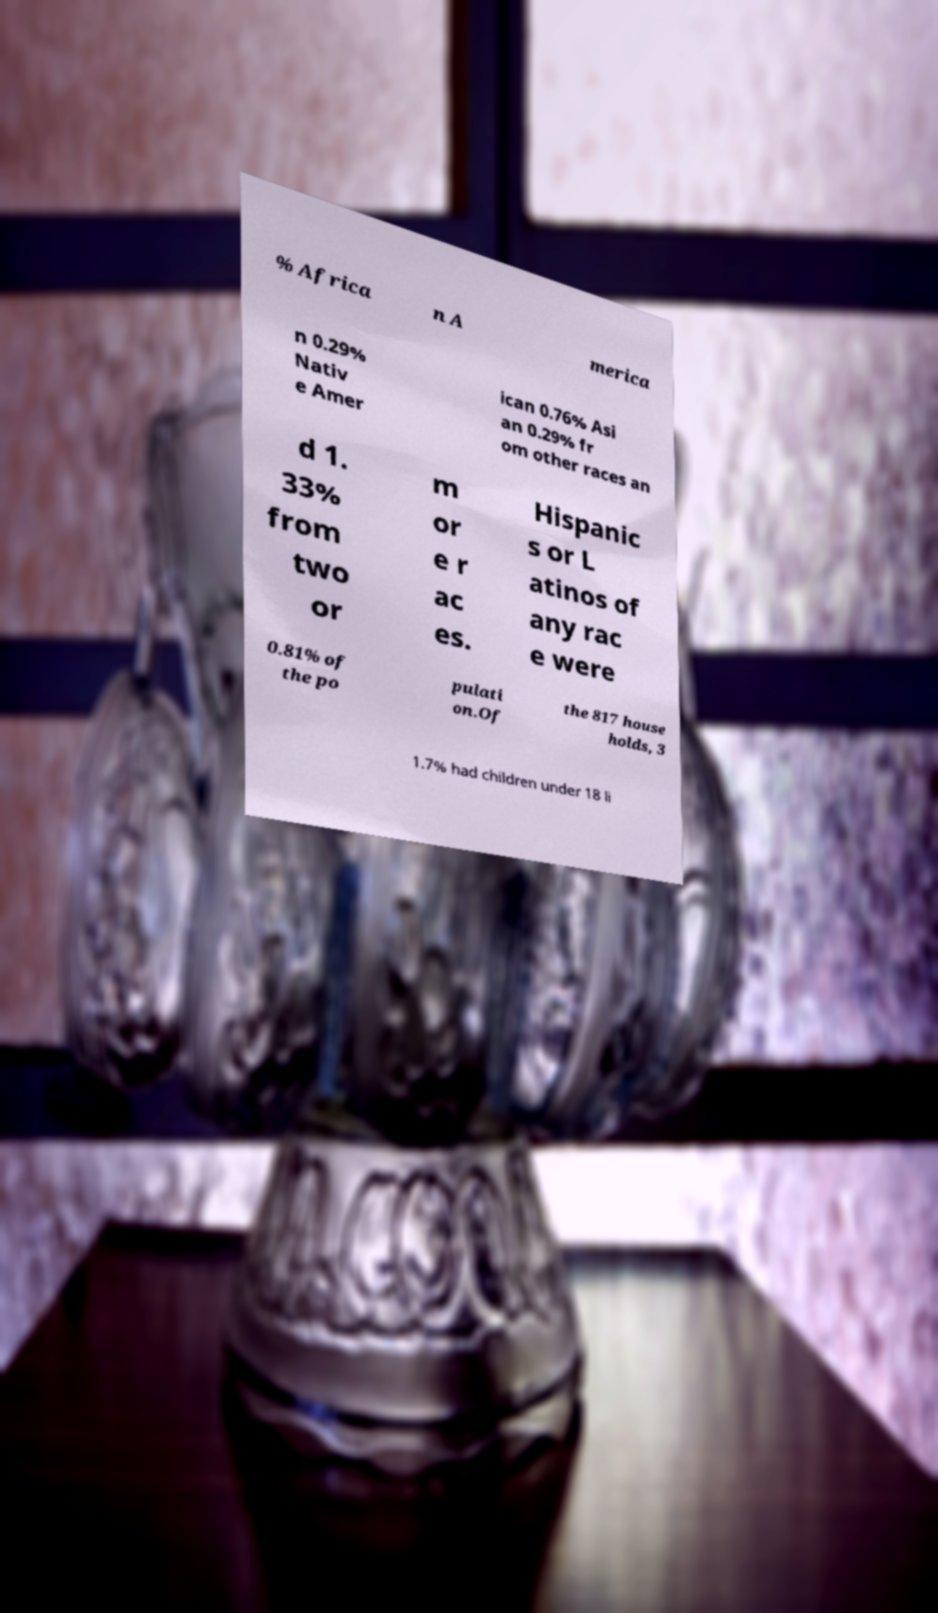What messages or text are displayed in this image? I need them in a readable, typed format. % Africa n A merica n 0.29% Nativ e Amer ican 0.76% Asi an 0.29% fr om other races an d 1. 33% from two or m or e r ac es. Hispanic s or L atinos of any rac e were 0.81% of the po pulati on.Of the 817 house holds, 3 1.7% had children under 18 li 